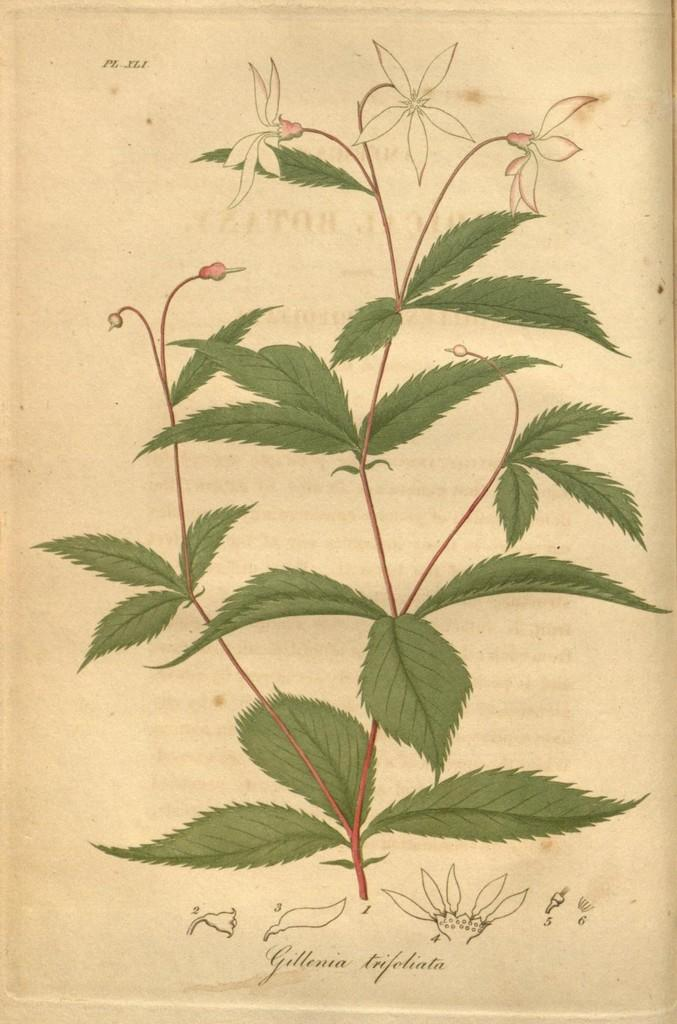What is the main subject of the image in the picture? The main subject is a painting of a plant with flowers on the paper. What else can be seen on the paper? There is writing on the paper. What type of bear can be seen in the painting on the paper? There is no bear present in the painting on the paper; it features a plant with flowers. 